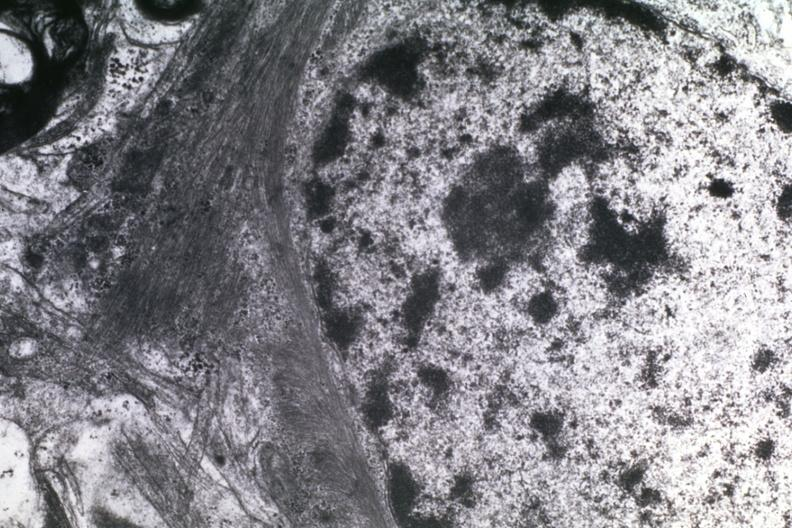what is present?
Answer the question using a single word or phrase. Brain 